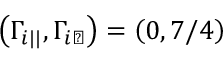Convert formula to latex. <formula><loc_0><loc_0><loc_500><loc_500>\left ( \Gamma _ { i | | } , \Gamma _ { i \perp } \right ) = \left ( 0 , 7 / 4 \right )</formula> 